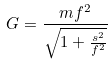<formula> <loc_0><loc_0><loc_500><loc_500>G = \frac { m f ^ { 2 } } { \sqrt { 1 + \frac { s ^ { 2 } } { f ^ { 2 } } } }</formula> 